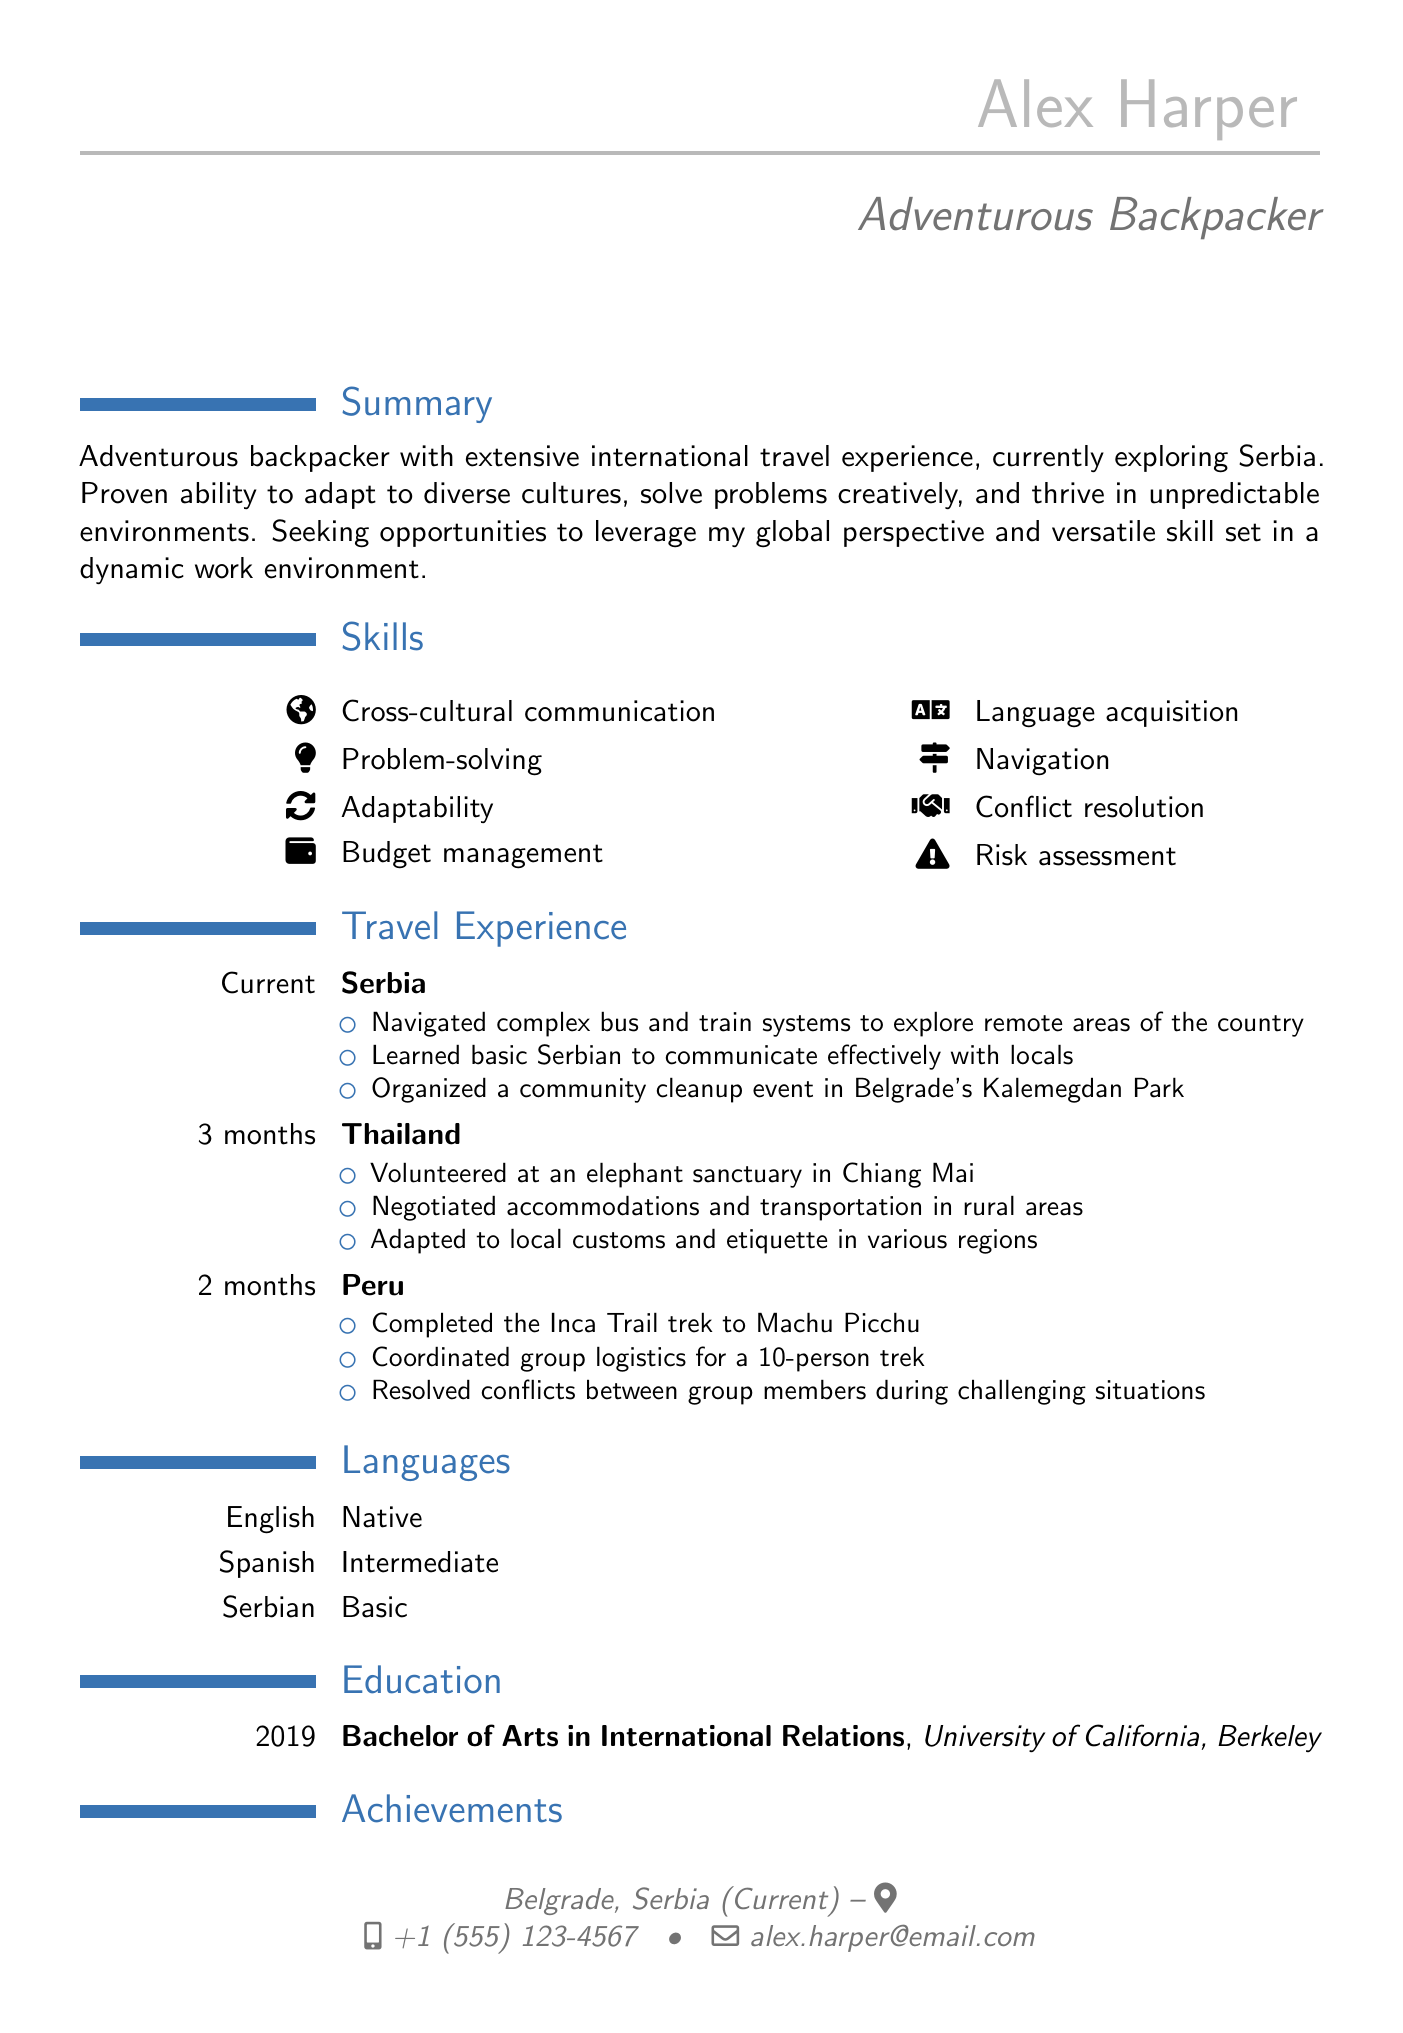what is the name of the backpacker? The backpacker's name is located at the top of the document under personal info.
Answer: Alex Harper what is the current location of the backpacker? The current location is provided in the personal info section of the document.
Answer: Belgrade, Serbia how many months did the backpacker travel in Thailand? The duration of travel in Thailand is specified in the travel experience section.
Answer: 3 months what degree did Alex Harper earn? The educational qualification is listed in the education section of the document.
Answer: Bachelor of Arts in International Relations which language does the backpacker have basic proficiency in? Language proficiency levels for various languages are detailed in the languages section.
Answer: Serbian how many highlights are listed under travel experience in Serbia? The highlights for Serbia are counted in the travel experience section.
Answer: 3 what unique event did Alex organize in Serbia? The document mentions an organized event under the highlights for Serbia.
Answer: Community cleanup which country did the backpacker volunteer in an elephant sanctuary? The travel experience highlights specify the country where the volunteering took place.
Answer: Thailand how much money did Alex raise for a school in Cusco, Peru? The achievement regarding fundraising is stated in the achievements section of the document.
Answer: $5,000 